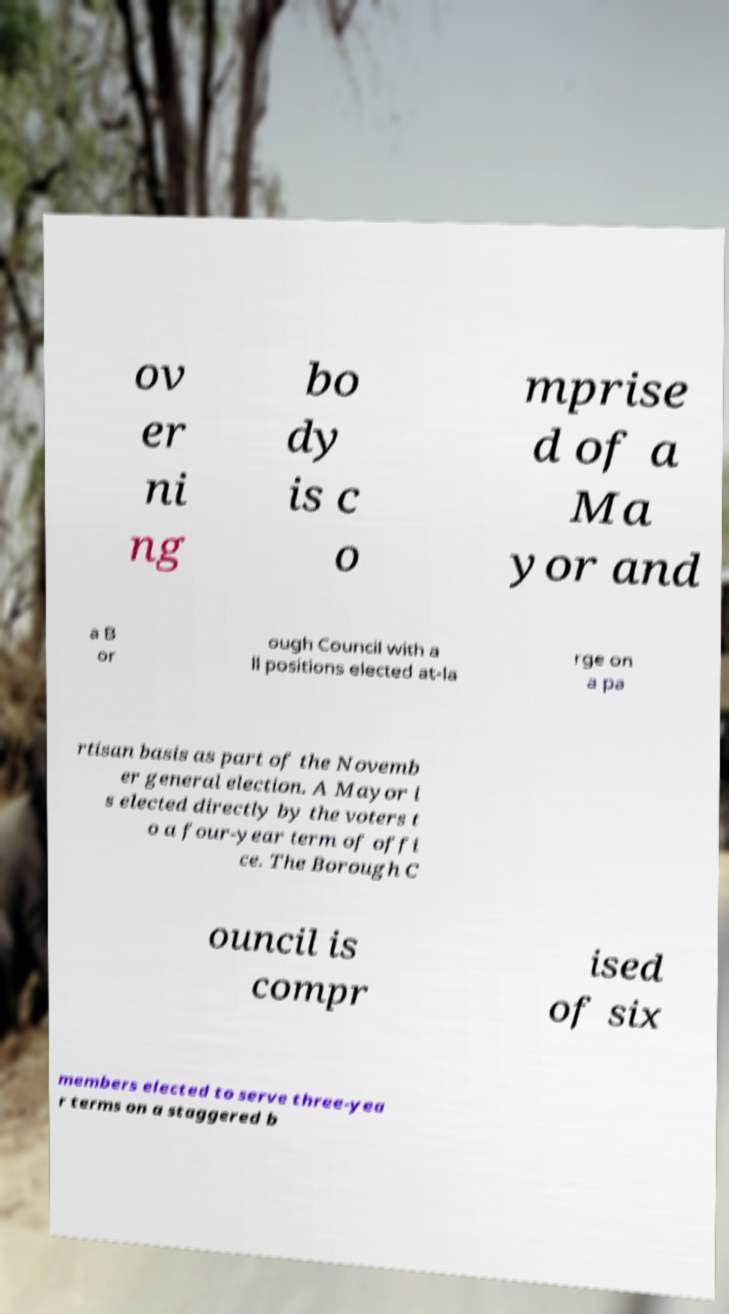Can you read and provide the text displayed in the image?This photo seems to have some interesting text. Can you extract and type it out for me? ov er ni ng bo dy is c o mprise d of a Ma yor and a B or ough Council with a ll positions elected at-la rge on a pa rtisan basis as part of the Novemb er general election. A Mayor i s elected directly by the voters t o a four-year term of offi ce. The Borough C ouncil is compr ised of six members elected to serve three-yea r terms on a staggered b 